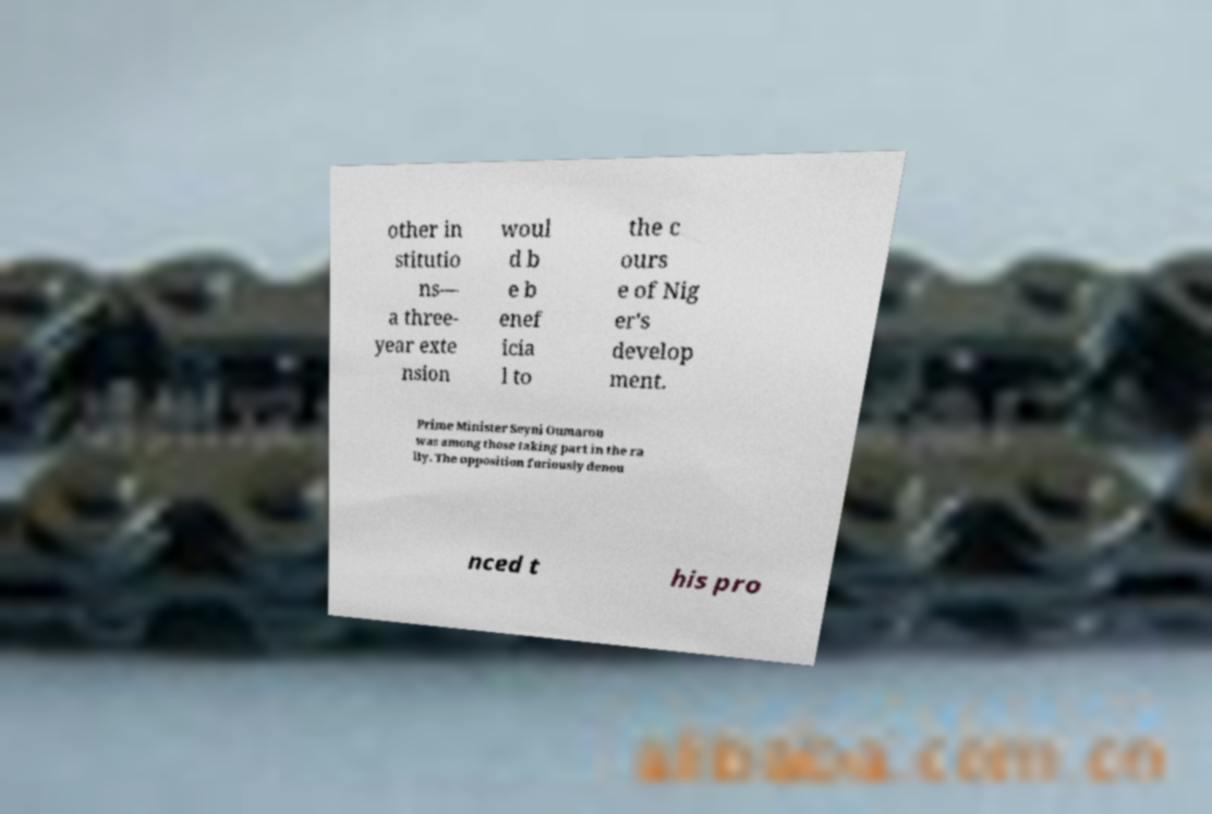Please read and relay the text visible in this image. What does it say? other in stitutio ns— a three- year exte nsion woul d b e b enef icia l to the c ours e of Nig er's develop ment. Prime Minister Seyni Oumarou was among those taking part in the ra lly. The opposition furiously denou nced t his pro 